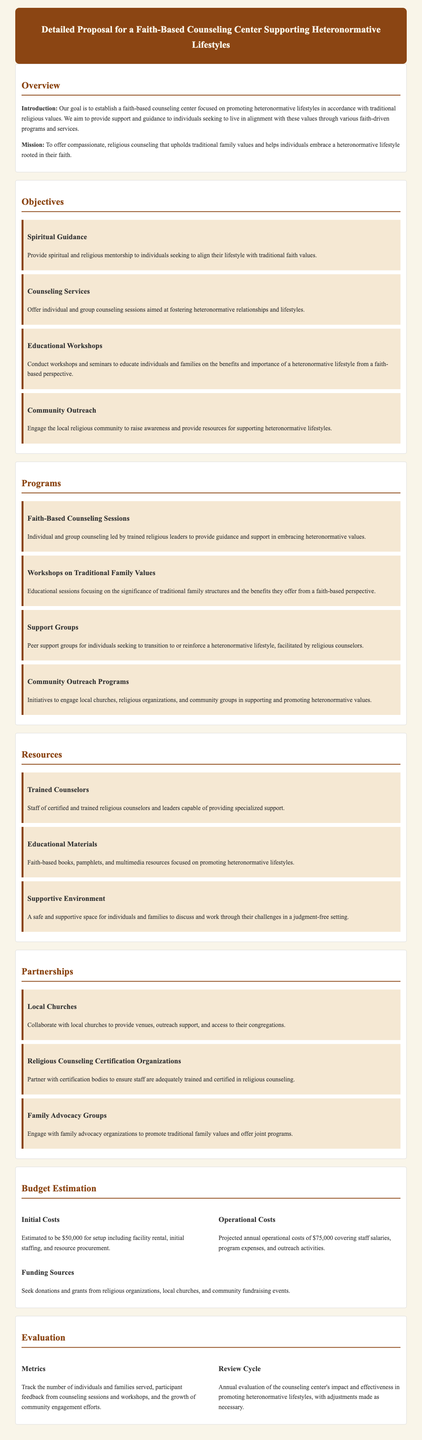What is the mission of the counseling center? The mission is outlined in the proposal, stating the purpose of offering support aligned with traditional family values.
Answer: To offer compassionate, religious counseling that upholds traditional family values and helps individuals embrace a heteronormative lifestyle rooted in their faith What is the estimated initial cost for setup? The document provides a specific figure for initial costs related to setting up the center.
Answer: $50,000 Name one type of program offered at the counseling center. The proposal lists various programs available at the counseling center.
Answer: Faith-Based Counseling Sessions What are the two main types of costs mentioned? The budget section distinguishes between two specific financial categories.
Answer: Initial Costs and Operational Costs How often will the counseling center’s impact be evaluated? The evaluation section specifies the frequency of the review regarding the center's effectiveness.
Answer: Annual What organization will the center collaborate with for community outreach? The proposal mentions local churches as partnership entities for engagement in outreach programs.
Answer: Local Churches What is one resource mentioned that will be provided at the center? The resources section outlines specific materials or supports the center will offer to clients.
Answer: Educational Materials How will the center track its effectiveness? The metrics listed in the evaluation section describe how the center will assess its impact.
Answer: The number of individuals and families served What type of support group is mentioned in the proposal? The document specifies a type of group intended for individuals transitioning to a heteronormative lifestyle.
Answer: Support Groups 